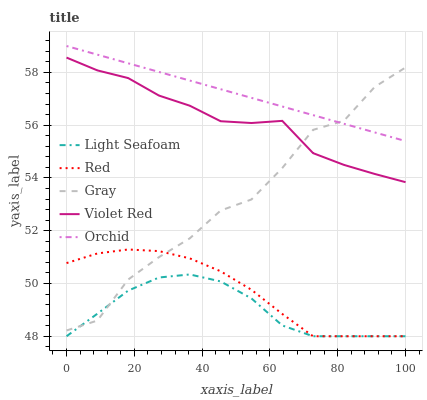Does Light Seafoam have the minimum area under the curve?
Answer yes or no. Yes. Does Orchid have the maximum area under the curve?
Answer yes or no. Yes. Does Violet Red have the minimum area under the curve?
Answer yes or no. No. Does Violet Red have the maximum area under the curve?
Answer yes or no. No. Is Orchid the smoothest?
Answer yes or no. Yes. Is Gray the roughest?
Answer yes or no. Yes. Is Violet Red the smoothest?
Answer yes or no. No. Is Violet Red the roughest?
Answer yes or no. No. Does Light Seafoam have the lowest value?
Answer yes or no. Yes. Does Violet Red have the lowest value?
Answer yes or no. No. Does Orchid have the highest value?
Answer yes or no. Yes. Does Violet Red have the highest value?
Answer yes or no. No. Is Light Seafoam less than Violet Red?
Answer yes or no. Yes. Is Orchid greater than Light Seafoam?
Answer yes or no. Yes. Does Red intersect Gray?
Answer yes or no. Yes. Is Red less than Gray?
Answer yes or no. No. Is Red greater than Gray?
Answer yes or no. No. Does Light Seafoam intersect Violet Red?
Answer yes or no. No. 